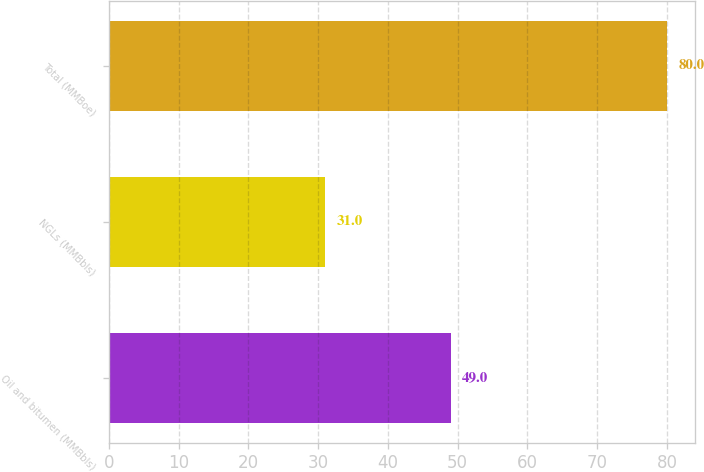Convert chart. <chart><loc_0><loc_0><loc_500><loc_500><bar_chart><fcel>Oil and bitumen (MMBbls)<fcel>NGLs (MMBbls)<fcel>Total (MMBoe)<nl><fcel>49<fcel>31<fcel>80<nl></chart> 